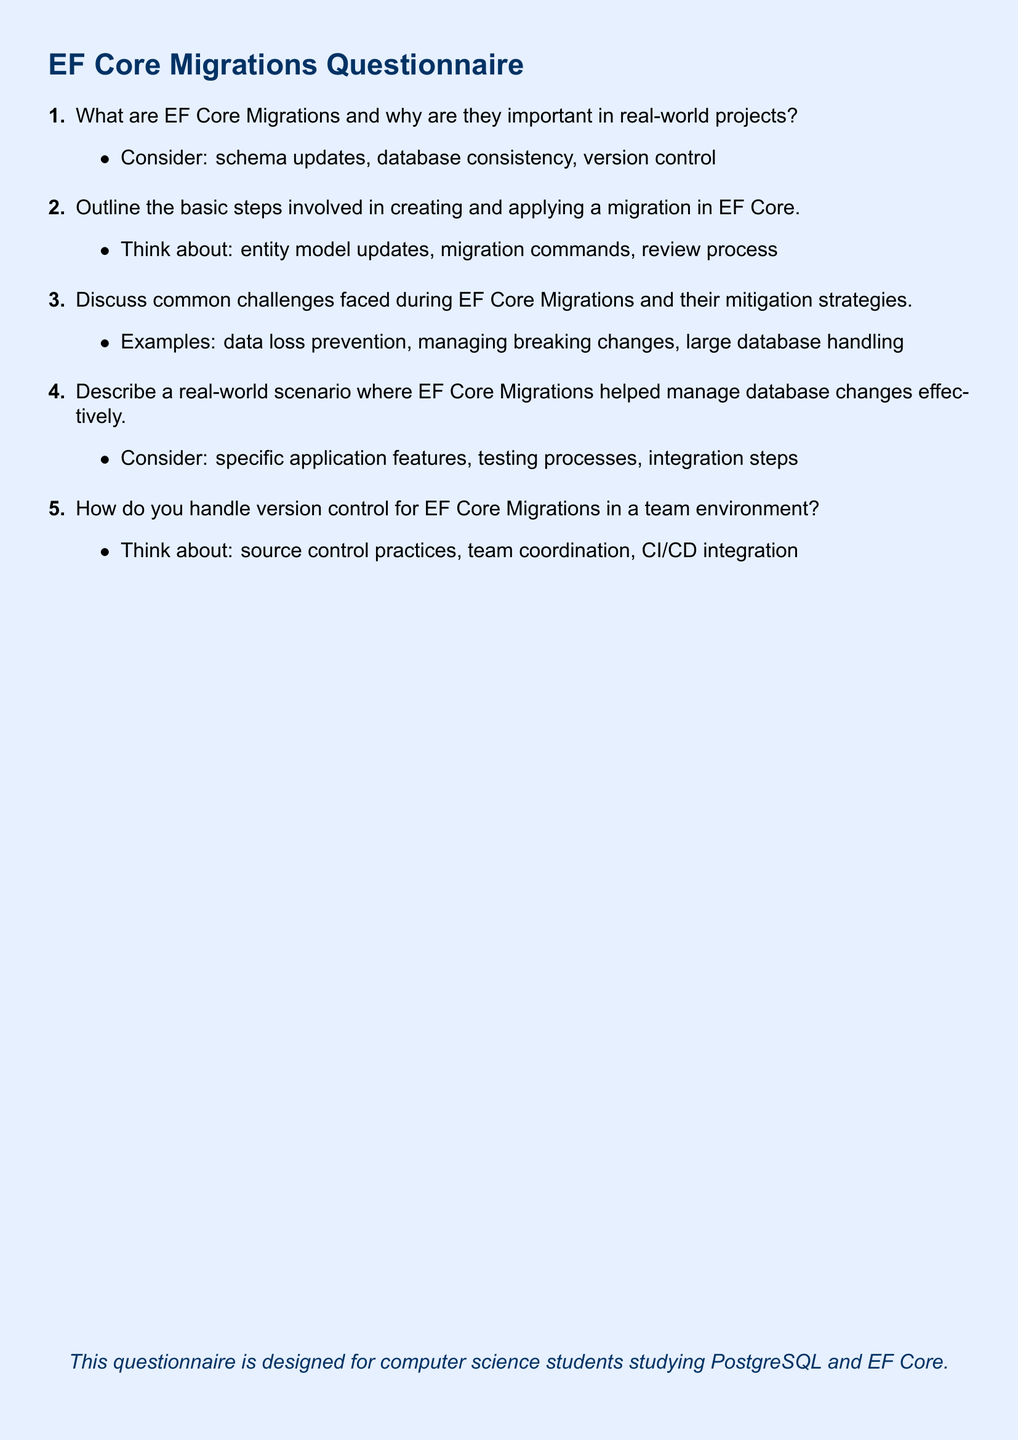What is the document about? The document is titled "EF Core Migrations Questionnaire" and focuses on knowledge and application of EF Core Migrations in real-world projects.
Answer: EF Core Migrations Questionnaire How many items are in the questionnaire? The document lists five items related to EF Core Migrations.
Answer: 5 What color is used for the page background? The document uses a light blue color for the page background.
Answer: light blue What is the main font used in the document? The document specifies Arial as the main font used throughout.
Answer: Arial What is one of the challenges mentioned in item three? The questionnaire outlines common challenges faced during EF Core Migrations, including data loss prevention.
Answer: data loss prevention In which section is the document intended for computer science students mentioned? The intended audience for the questionnaire is highlighted at the end in a separate text.
Answer: end of the document What is one specific topic discussed in item four? Item four describes real-world scenarios where EF Core Migrations were effective in managing database changes, focusing on application features.
Answer: application features 